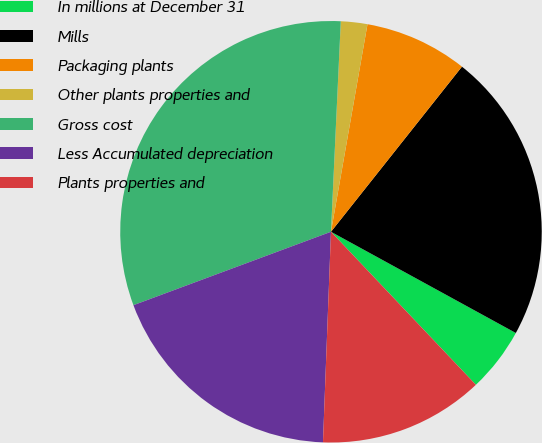<chart> <loc_0><loc_0><loc_500><loc_500><pie_chart><fcel>In millions at December 31<fcel>Mills<fcel>Packaging plants<fcel>Other plants properties and<fcel>Gross cost<fcel>Less Accumulated depreciation<fcel>Plants properties and<nl><fcel>4.96%<fcel>22.3%<fcel>7.9%<fcel>2.03%<fcel>31.4%<fcel>18.73%<fcel>12.67%<nl></chart> 